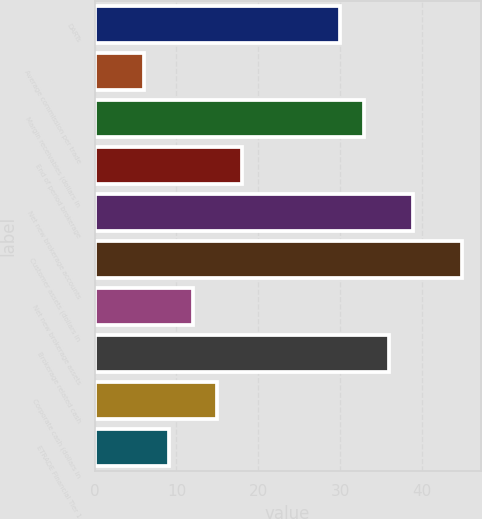Convert chart to OTSL. <chart><loc_0><loc_0><loc_500><loc_500><bar_chart><fcel>DARTs<fcel>Average commission per trade<fcel>Margin receivables (dollars in<fcel>End of period brokerage<fcel>Net new brokerage accounts<fcel>Customer assets (dollars in<fcel>Net new brokerage assets<fcel>Brokerage related cash<fcel>Corporate cash (dollars in<fcel>ETRADE Financial Tier 1<nl><fcel>29.96<fcel>6.04<fcel>32.95<fcel>18<fcel>38.93<fcel>44.91<fcel>12.02<fcel>35.94<fcel>15.01<fcel>9.03<nl></chart> 